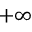<formula> <loc_0><loc_0><loc_500><loc_500>+ \infty</formula> 